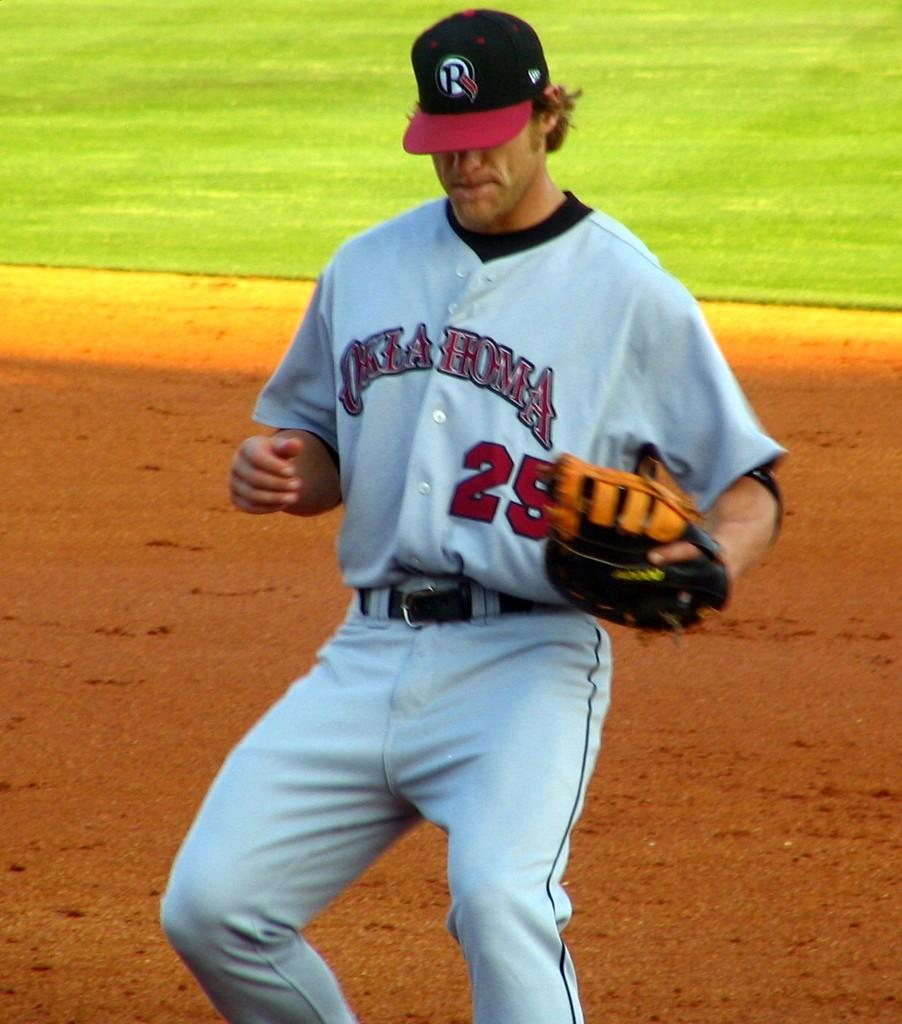<image>
Share a concise interpretation of the image provided. Oklahoma jersey worn on a player that is playing baseball 